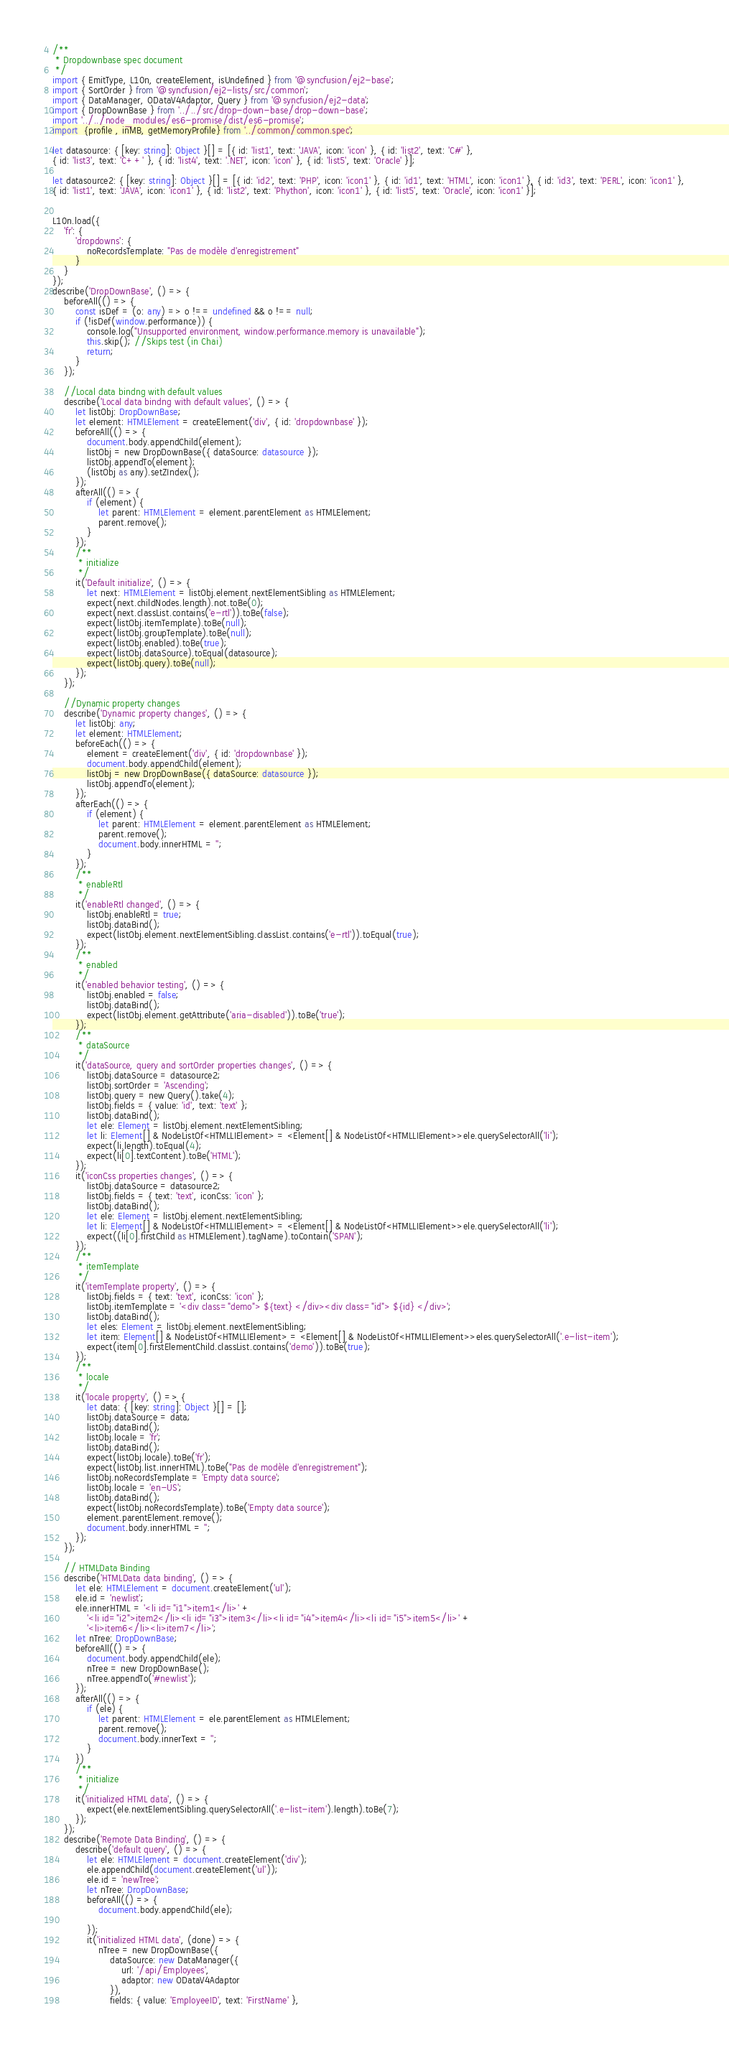Convert code to text. <code><loc_0><loc_0><loc_500><loc_500><_TypeScript_>/**
 * Dropdownbase spec document
 */
import { EmitType, L10n, createElement, isUndefined } from '@syncfusion/ej2-base';
import { SortOrder } from '@syncfusion/ej2-lists/src/common';
import { DataManager, ODataV4Adaptor, Query } from '@syncfusion/ej2-data';
import { DropDownBase } from '../../src/drop-down-base/drop-down-base';
import '../../node_modules/es6-promise/dist/es6-promise';
import  {profile , inMB, getMemoryProfile} from '../common/common.spec';

let datasource: { [key: string]: Object }[] = [{ id: 'list1', text: 'JAVA', icon: 'icon' }, { id: 'list2', text: 'C#' },
{ id: 'list3', text: 'C++' }, { id: 'list4', text: '.NET', icon: 'icon' }, { id: 'list5', text: 'Oracle' }];

let datasource2: { [key: string]: Object }[] = [{ id: 'id2', text: 'PHP', icon: 'icon1' }, { id: 'id1', text: 'HTML', icon: 'icon1' }, { id: 'id3', text: 'PERL', icon: 'icon1' },
{ id: 'list1', text: 'JAVA', icon: 'icon1' }, { id: 'list2', text: 'Phython', icon: 'icon1' }, { id: 'list5', text: 'Oracle', icon: 'icon1' }];


L10n.load({
    'fr': {
        'dropdowns': {
            noRecordsTemplate: "Pas de modèle d'enregistrement"
        }
    }
});
describe('DropDownBase', () => {
    beforeAll(() => {
        const isDef = (o: any) => o !== undefined && o !== null;
        if (!isDef(window.performance)) {
            console.log("Unsupported environment, window.performance.memory is unavailable");
            this.skip(); //Skips test (in Chai)
            return;
        }
    });

    //Local data bindng with default values
    describe('Local data bindng with default values', () => {
        let listObj: DropDownBase;
        let element: HTMLElement = createElement('div', { id: 'dropdownbase' });
        beforeAll(() => {
            document.body.appendChild(element);
            listObj = new DropDownBase({ dataSource: datasource });
            listObj.appendTo(element);
            (listObj as any).setZIndex();
        });
        afterAll(() => {
            if (element) {
                let parent: HTMLElement = element.parentElement as HTMLElement;
                parent.remove();
            }
        });
        /**
         * initialize
         */
        it('Default initialize', () => {
            let next: HTMLElement = listObj.element.nextElementSibling as HTMLElement;
            expect(next.childNodes.length).not.toBe(0);
            expect(next.classList.contains('e-rtl')).toBe(false);
            expect(listObj.itemTemplate).toBe(null);
            expect(listObj.groupTemplate).toBe(null);
            expect(listObj.enabled).toBe(true);
            expect(listObj.dataSource).toEqual(datasource);
            expect(listObj.query).toBe(null);
        });
    });

    //Dynamic property changes
    describe('Dynamic property changes', () => {
        let listObj: any;
        let element: HTMLElement;
        beforeEach(() => {
            element = createElement('div', { id: 'dropdownbase' });
            document.body.appendChild(element);
            listObj = new DropDownBase({ dataSource: datasource });
            listObj.appendTo(element);
        });
        afterEach(() => {
            if (element) {
                let parent: HTMLElement = element.parentElement as HTMLElement;
                parent.remove();
                document.body.innerHTML = '';
            }
        });
        /**
         * enableRtl
         */
        it('enableRtl changed', () => {
            listObj.enableRtl = true;
            listObj.dataBind();
            expect(listObj.element.nextElementSibling.classList.contains('e-rtl')).toEqual(true);
        });
        /**
         * enabled
         */
        it('enabled behavior testing', () => {
            listObj.enabled = false;
            listObj.dataBind();
            expect(listObj.element.getAttribute('aria-disabled')).toBe('true');
        });
        /**
         * dataSource
         */
        it('dataSource, query and sortOrder properties changes', () => {
            listObj.dataSource = datasource2;
            listObj.sortOrder = 'Ascending';
            listObj.query = new Query().take(4);
            listObj.fields = { value: 'id', text: 'text' };
            listObj.dataBind();
            let ele: Element = listObj.element.nextElementSibling;
            let li: Element[] & NodeListOf<HTMLLIElement> = <Element[] & NodeListOf<HTMLLIElement>>ele.querySelectorAll('li');
            expect(li.length).toEqual(4);
            expect(li[0].textContent).toBe('HTML');
        });
        it('iconCss properties changes', () => {
            listObj.dataSource = datasource2;
            listObj.fields = { text: 'text', iconCss: 'icon' };
            listObj.dataBind();
            let ele: Element = listObj.element.nextElementSibling;
            let li: Element[] & NodeListOf<HTMLLIElement> = <Element[] & NodeListOf<HTMLLIElement>>ele.querySelectorAll('li');
            expect((li[0].firstChild as HTMLElement).tagName).toContain('SPAN');
        });
        /**
         * itemTemplate
         */
        it('itemTemplate property', () => {
            listObj.fields = { text: 'text', iconCss: 'icon' };
            listObj.itemTemplate = '<div class="demo"> ${text} </div><div class="id"> ${id} </div>';
            listObj.dataBind();
            let eles: Element = listObj.element.nextElementSibling;
            let item: Element[] & NodeListOf<HTMLLIElement> = <Element[] & NodeListOf<HTMLLIElement>>eles.querySelectorAll('.e-list-item');
            expect(item[0].firstElementChild.classList.contains('demo')).toBe(true);
        });
        /**
         * locale
         */
        it('locale property', () => {
            let data: { [key: string]: Object }[] = [];
            listObj.dataSource = data;
            listObj.dataBind();
            listObj.locale = 'fr';
            listObj.dataBind();
            expect(listObj.locale).toBe('fr');
            expect(listObj.list.innerHTML).toBe("Pas de modèle d'enregistrement");
            listObj.noRecordsTemplate = 'Empty data source';
            listObj.locale = 'en-US';
            listObj.dataBind();
            expect(listObj.noRecordsTemplate).toBe('Empty data source');
            element.parentElement.remove();
            document.body.innerHTML = '';
        });
    });

    // HTMLData Binding
    describe('HTMLData data binding', () => {
        let ele: HTMLElement = document.createElement('ul');
        ele.id = 'newlist';
        ele.innerHTML = '<li id="i1">item1</li>' +
            '<li id="i2">item2</li><li id="i3">item3</li><li id="i4">item4</li><li id="i5">item5</li>' +
            '<li>item6</li><li>item7</li>';
        let nTree: DropDownBase;
        beforeAll(() => {
            document.body.appendChild(ele);
            nTree = new DropDownBase();
            nTree.appendTo('#newlist');
        });
        afterAll(() => {
            if (ele) {
                let parent: HTMLElement = ele.parentElement as HTMLElement;
                parent.remove();
                document.body.innerText = '';
            }
        })
        /**
         * initialize
         */
        it('initialized HTML data', () => {
            expect(ele.nextElementSibling.querySelectorAll('.e-list-item').length).toBe(7);
        });
    });
    describe('Remote Data Binding', () => {
        describe('default query', () => {
            let ele: HTMLElement = document.createElement('div');
            ele.appendChild(document.createElement('ul'));
            ele.id = 'newTree';
            let nTree: DropDownBase;
            beforeAll(() => {
                document.body.appendChild(ele);

            });
            it('initialized HTML data', (done) => {
                nTree = new DropDownBase({
                    dataSource: new DataManager({
                        url: '/api/Employees',
                        adaptor: new ODataV4Adaptor
                    }),
                    fields: { value: 'EmployeeID', text: 'FirstName' },</code> 